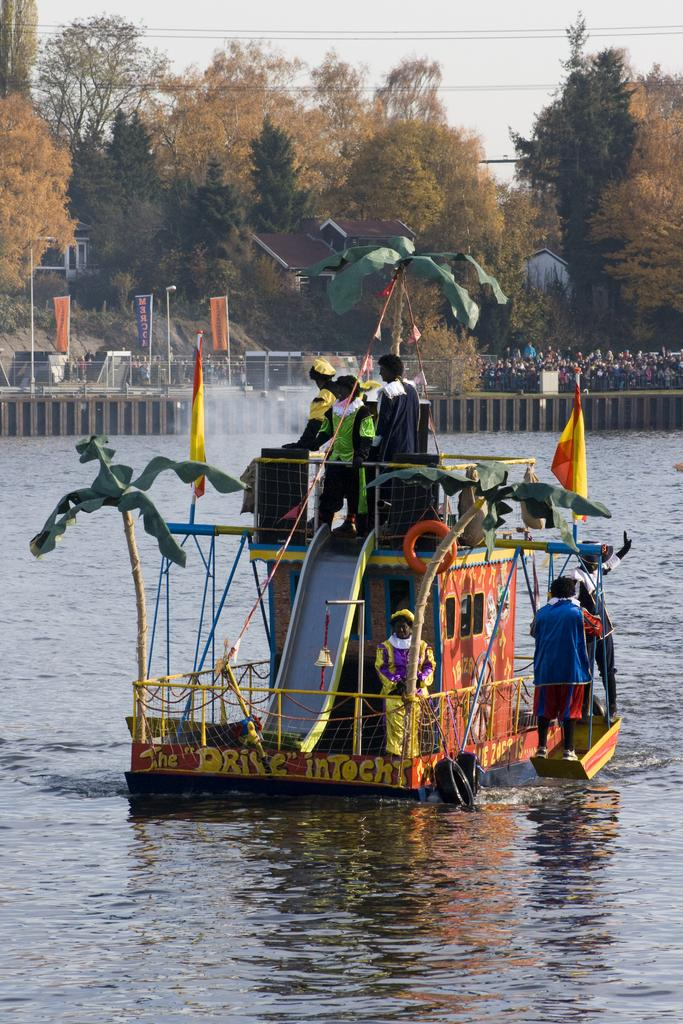What are the people in the image doing? The people in the image are on a boat. What is the boat floating on? The boat is floating on water. What can be seen in the background of the image? Trees are visible at the top of the image. What type of iron is being used by the monkey in the image? There is no monkey or iron present in the image. 